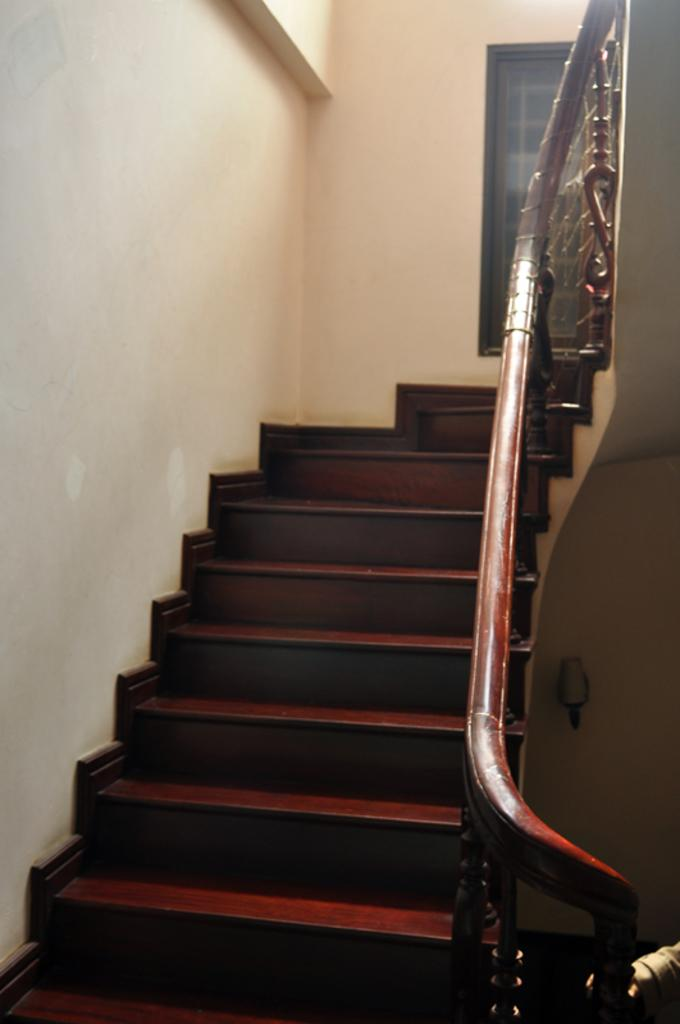What type of structure is present in the image? There is a staircase in the image. What feature is present alongside the staircase? There is a hand railing in the image. What color is the wall on the left side of the image? The wall on the left side of the image is painted white. What can be seen in the background of the image? There is a window in the background of the image. What type of work is the governor doing in the image? There is no governor present in the image, so it is not possible to determine what work they might be doing. 